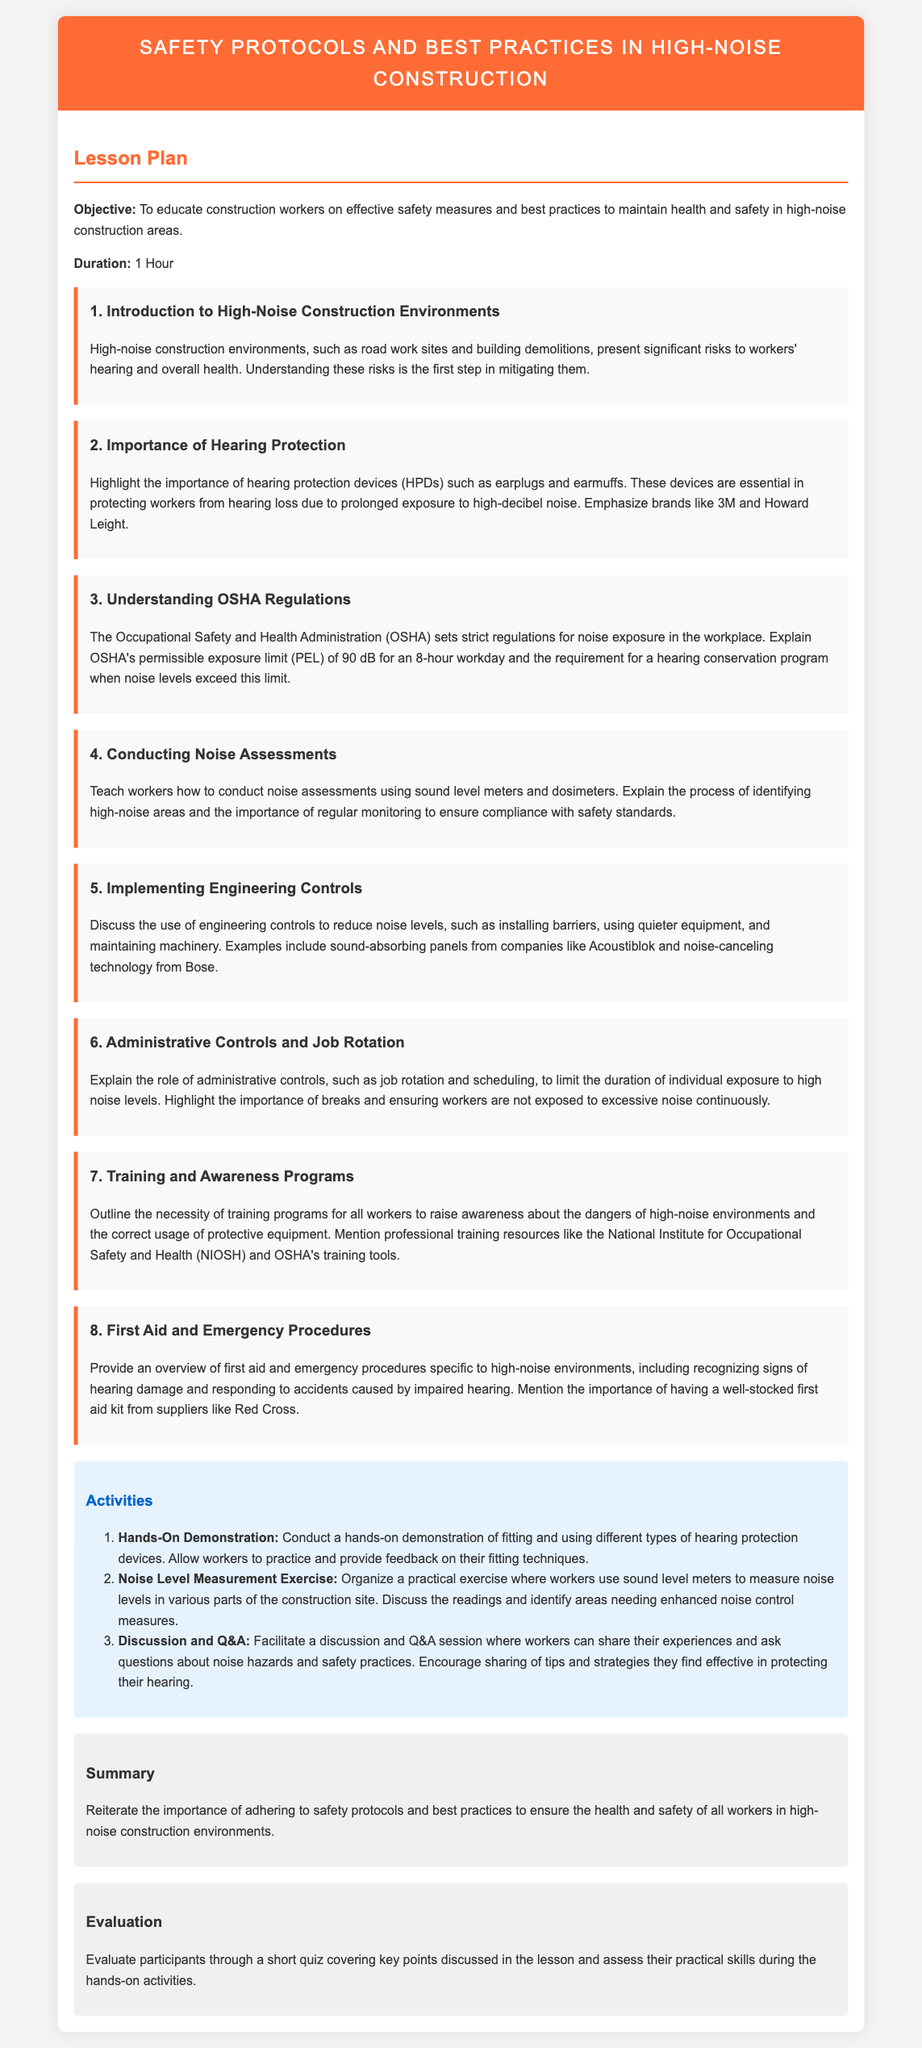What is the objective of the lesson plan? The objective is to educate construction workers on effective safety measures and best practices to maintain health and safety in high-noise construction areas.
Answer: To educate construction workers on effective safety measures and best practices How long is the lesson duration? The duration of the lesson is explicitly mentioned in the document.
Answer: 1 Hour What is the permissible exposure limit set by OSHA? OSHA's permissible exposure limit (PEL) is defined in the context of noise exposure regulations.
Answer: 90 dB Which device brands are highlighted for hearing protection? The section discussing the importance of hearing protection devices mentions specific brands.
Answer: 3M and Howard Leight What activity involves measuring noise levels? An activity described in the lesson plan involves a practical exercise related to noise measurement.
Answer: Noise Level Measurement Exercise What are examples of engineering controls mentioned? The document describes certain measures under engineering controls to reduce noise levels.
Answer: Sound-absorbing panels and noise-canceling technology Why are administrative controls emphasized in the lesson? The lesson emphasizes administrative controls to limit exposure duration among workers in high-noise levels.
Answer: To limit the duration of individual exposure to high noise levels What first aid resources are mentioned? Resources for first aid specific to high-noise environments are indicated in the document.
Answer: Red Cross How will participants be evaluated? The evaluation process for participants includes a specific type of assessment mentioned in the lesson plan.
Answer: Short quiz and practical skills assessment 